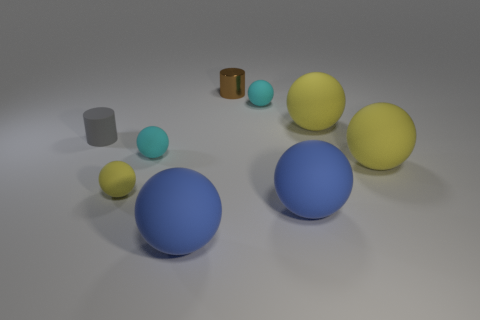What can you tell me about the surface the objects are resting on? The surface appears to be a flat, smooth, matte-finish plane that generates reflections, indicating it might be made of a material like frosted glass or a similarly semi-reflective matte material. 